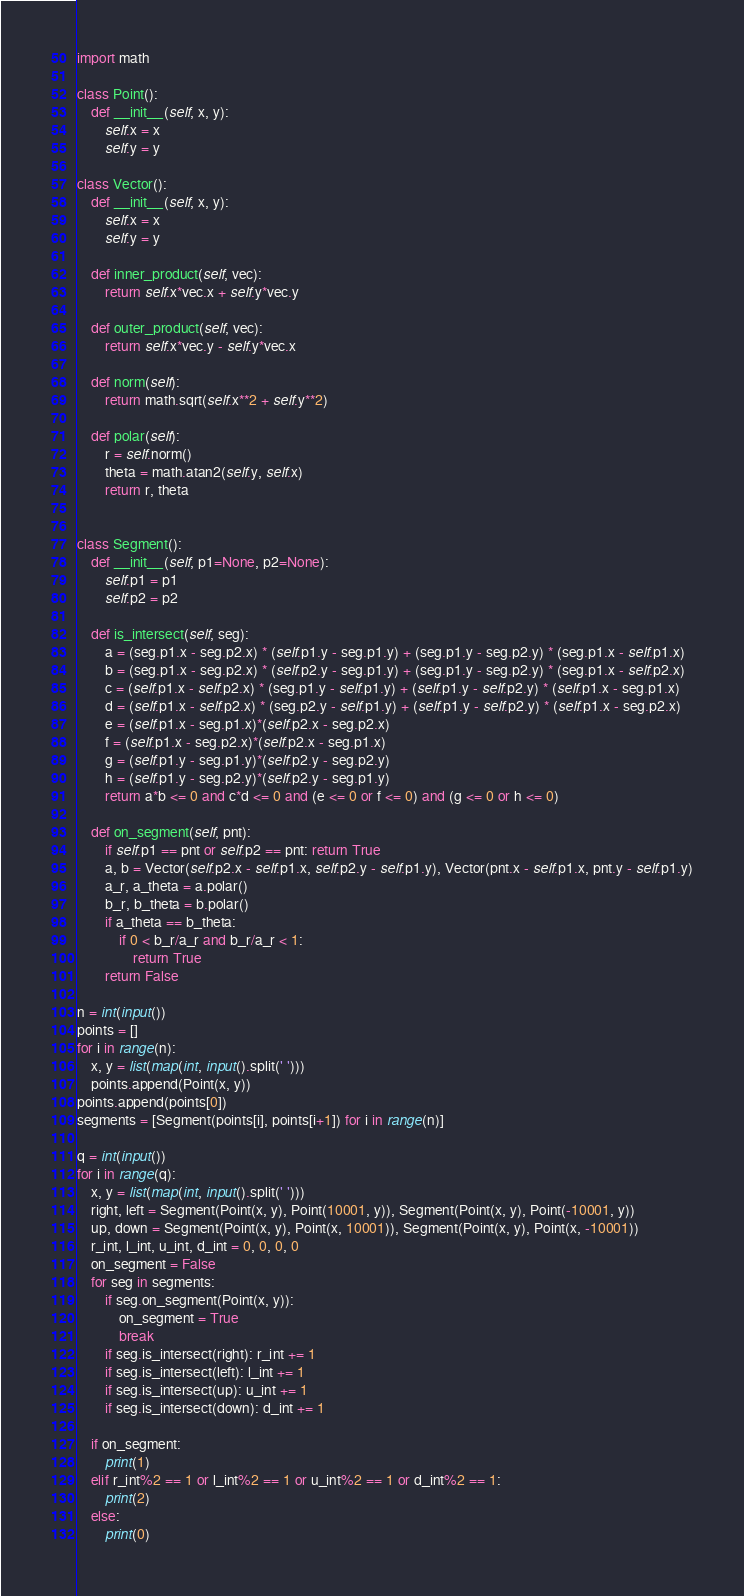<code> <loc_0><loc_0><loc_500><loc_500><_Python_>import math

class Point():
    def __init__(self, x, y):
        self.x = x
        self.y = y

class Vector():
    def __init__(self, x, y):
        self.x = x
        self.y = y

    def inner_product(self, vec):
        return self.x*vec.x + self.y*vec.y

    def outer_product(self, vec):
        return self.x*vec.y - self.y*vec.x

    def norm(self):
        return math.sqrt(self.x**2 + self.y**2)

    def polar(self):
        r = self.norm()
        theta = math.atan2(self.y, self.x)
        return r, theta


class Segment():
    def __init__(self, p1=None, p2=None):
        self.p1 = p1
        self.p2 = p2

    def is_intersect(self, seg):
        a = (seg.p1.x - seg.p2.x) * (self.p1.y - seg.p1.y) + (seg.p1.y - seg.p2.y) * (seg.p1.x - self.p1.x)
        b = (seg.p1.x - seg.p2.x) * (self.p2.y - seg.p1.y) + (seg.p1.y - seg.p2.y) * (seg.p1.x - self.p2.x)
        c = (self.p1.x - self.p2.x) * (seg.p1.y - self.p1.y) + (self.p1.y - self.p2.y) * (self.p1.x - seg.p1.x)
        d = (self.p1.x - self.p2.x) * (seg.p2.y - self.p1.y) + (self.p1.y - self.p2.y) * (self.p1.x - seg.p2.x)
        e = (self.p1.x - seg.p1.x)*(self.p2.x - seg.p2.x)
        f = (self.p1.x - seg.p2.x)*(self.p2.x - seg.p1.x)
        g = (self.p1.y - seg.p1.y)*(self.p2.y - seg.p2.y)
        h = (self.p1.y - seg.p2.y)*(self.p2.y - seg.p1.y)
        return a*b <= 0 and c*d <= 0 and (e <= 0 or f <= 0) and (g <= 0 or h <= 0)

    def on_segment(self, pnt):
        if self.p1 == pnt or self.p2 == pnt: return True
        a, b = Vector(self.p2.x - self.p1.x, self.p2.y - self.p1.y), Vector(pnt.x - self.p1.x, pnt.y - self.p1.y)
        a_r, a_theta = a.polar()
        b_r, b_theta = b.polar()
        if a_theta == b_theta:
            if 0 < b_r/a_r and b_r/a_r < 1:
                return True
        return False

n = int(input())
points = []
for i in range(n):
    x, y = list(map(int, input().split(' ')))
    points.append(Point(x, y))
points.append(points[0])
segments = [Segment(points[i], points[i+1]) for i in range(n)]

q = int(input())
for i in range(q):
    x, y = list(map(int, input().split(' ')))
    right, left = Segment(Point(x, y), Point(10001, y)), Segment(Point(x, y), Point(-10001, y))
    up, down = Segment(Point(x, y), Point(x, 10001)), Segment(Point(x, y), Point(x, -10001))
    r_int, l_int, u_int, d_int = 0, 0, 0, 0
    on_segment = False
    for seg in segments:
        if seg.on_segment(Point(x, y)):
            on_segment = True
            break
        if seg.is_intersect(right): r_int += 1
        if seg.is_intersect(left): l_int += 1
        if seg.is_intersect(up): u_int += 1
        if seg.is_intersect(down): d_int += 1

    if on_segment:
        print(1)
    elif r_int%2 == 1 or l_int%2 == 1 or u_int%2 == 1 or d_int%2 == 1:
        print(2)
    else:
        print(0)
</code> 